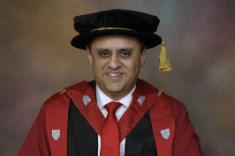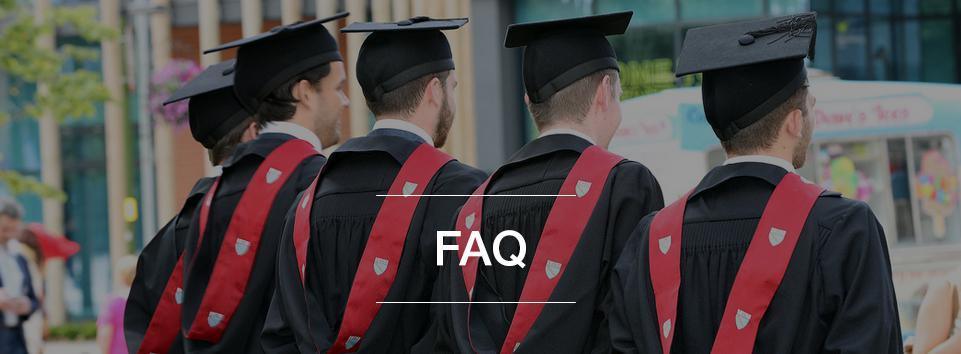The first image is the image on the left, the second image is the image on the right. Examine the images to the left and right. Is the description "Each image shows at least three graduates standing together wearing black gowns with red trim and black mortarboards" accurate? Answer yes or no. No. The first image is the image on the left, the second image is the image on the right. For the images shown, is this caption "An image shows three female graduates posing together wearing black grad caps." true? Answer yes or no. No. 